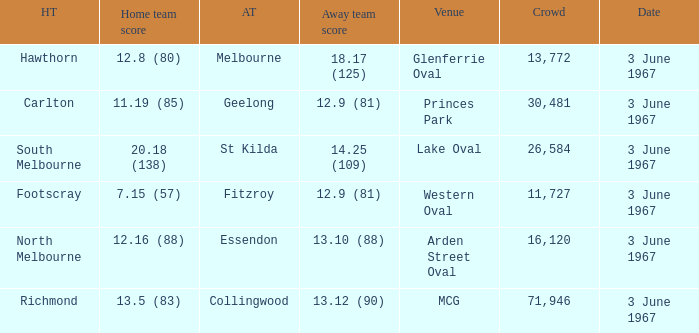What was Hawthorn's score as the home team? 12.8 (80). 